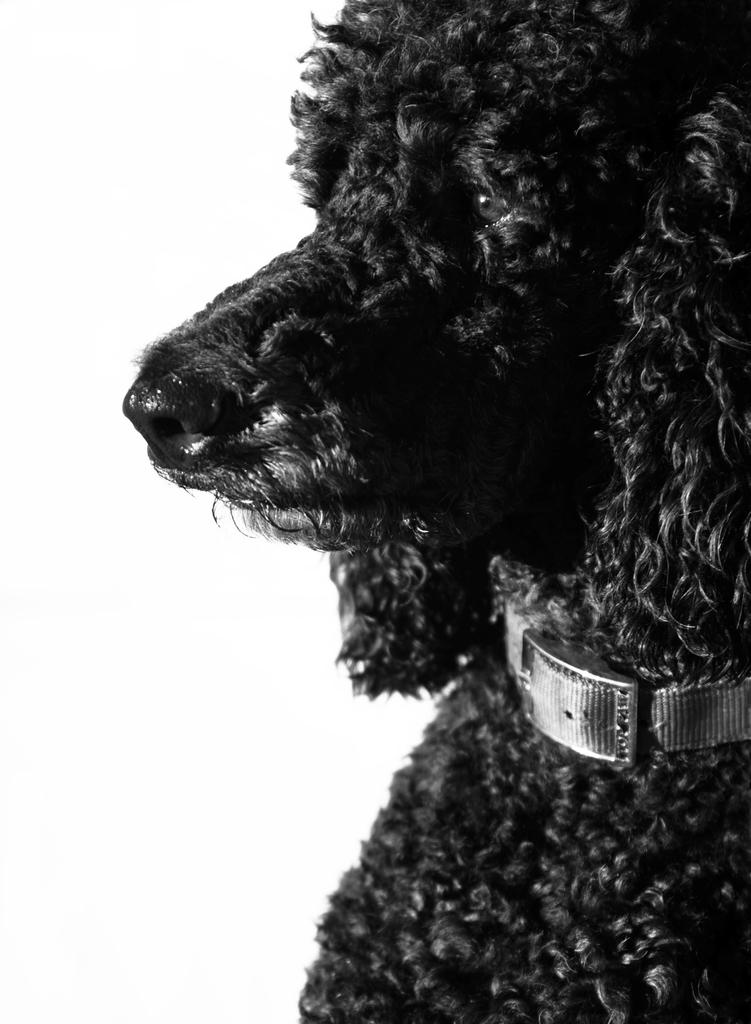What type of animal is in the image? There is a dog in the image. What is the color of the dog? The dog is black in color. What other object is visible in the image? There is a belt visible in the image. What type of cent can be seen in the image? There is no cent present in the image. What humorous effect does the dog have on the belt in the image? There is no humorous effect or interaction between the dog and the belt in the image. 